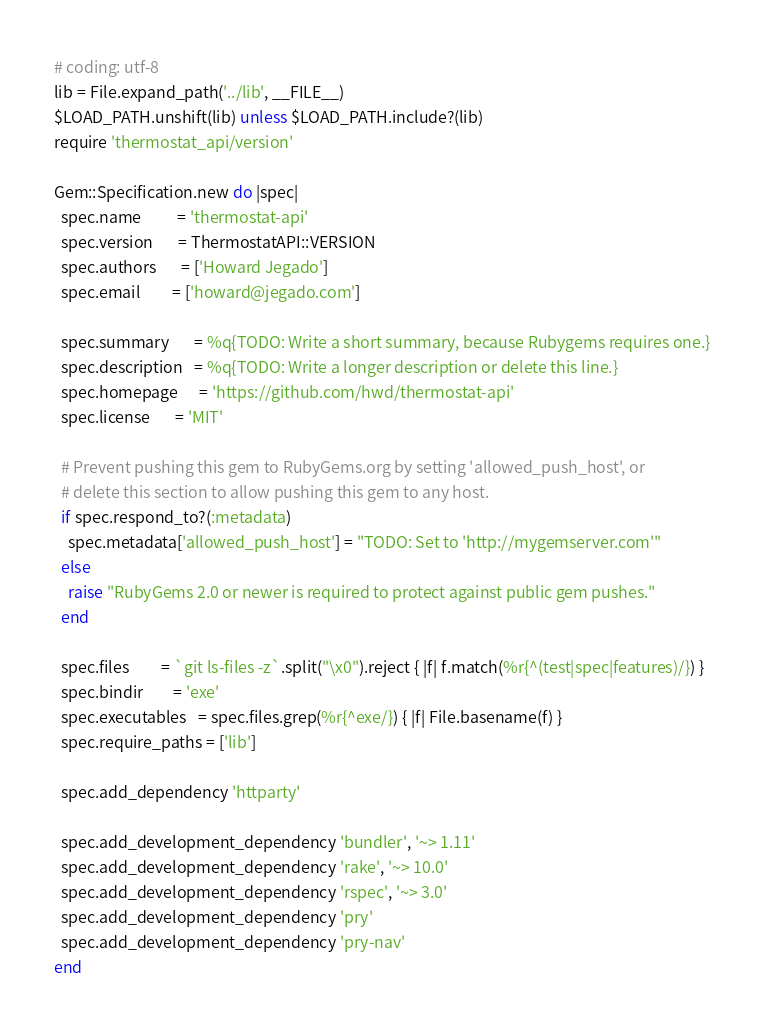Convert code to text. <code><loc_0><loc_0><loc_500><loc_500><_Ruby_># coding: utf-8
lib = File.expand_path('../lib', __FILE__)
$LOAD_PATH.unshift(lib) unless $LOAD_PATH.include?(lib)
require 'thermostat_api/version'

Gem::Specification.new do |spec|
  spec.name          = 'thermostat-api'
  spec.version       = ThermostatAPI::VERSION
  spec.authors       = ['Howard Jegado']
  spec.email         = ['howard@jegado.com']

  spec.summary       = %q{TODO: Write a short summary, because Rubygems requires one.}
  spec.description   = %q{TODO: Write a longer description or delete this line.}
  spec.homepage      = 'https://github.com/hwd/thermostat-api'
  spec.license       = 'MIT'

  # Prevent pushing this gem to RubyGems.org by setting 'allowed_push_host', or
  # delete this section to allow pushing this gem to any host.
  if spec.respond_to?(:metadata)
    spec.metadata['allowed_push_host'] = "TODO: Set to 'http://mygemserver.com'"
  else
    raise "RubyGems 2.0 or newer is required to protect against public gem pushes."
  end

  spec.files         = `git ls-files -z`.split("\x0").reject { |f| f.match(%r{^(test|spec|features)/}) }
  spec.bindir        = 'exe'
  spec.executables   = spec.files.grep(%r{^exe/}) { |f| File.basename(f) }
  spec.require_paths = ['lib']

  spec.add_dependency 'httparty'

  spec.add_development_dependency 'bundler', '~> 1.11'
  spec.add_development_dependency 'rake', '~> 10.0'
  spec.add_development_dependency 'rspec', '~> 3.0'
  spec.add_development_dependency 'pry'
  spec.add_development_dependency 'pry-nav'
end
</code> 